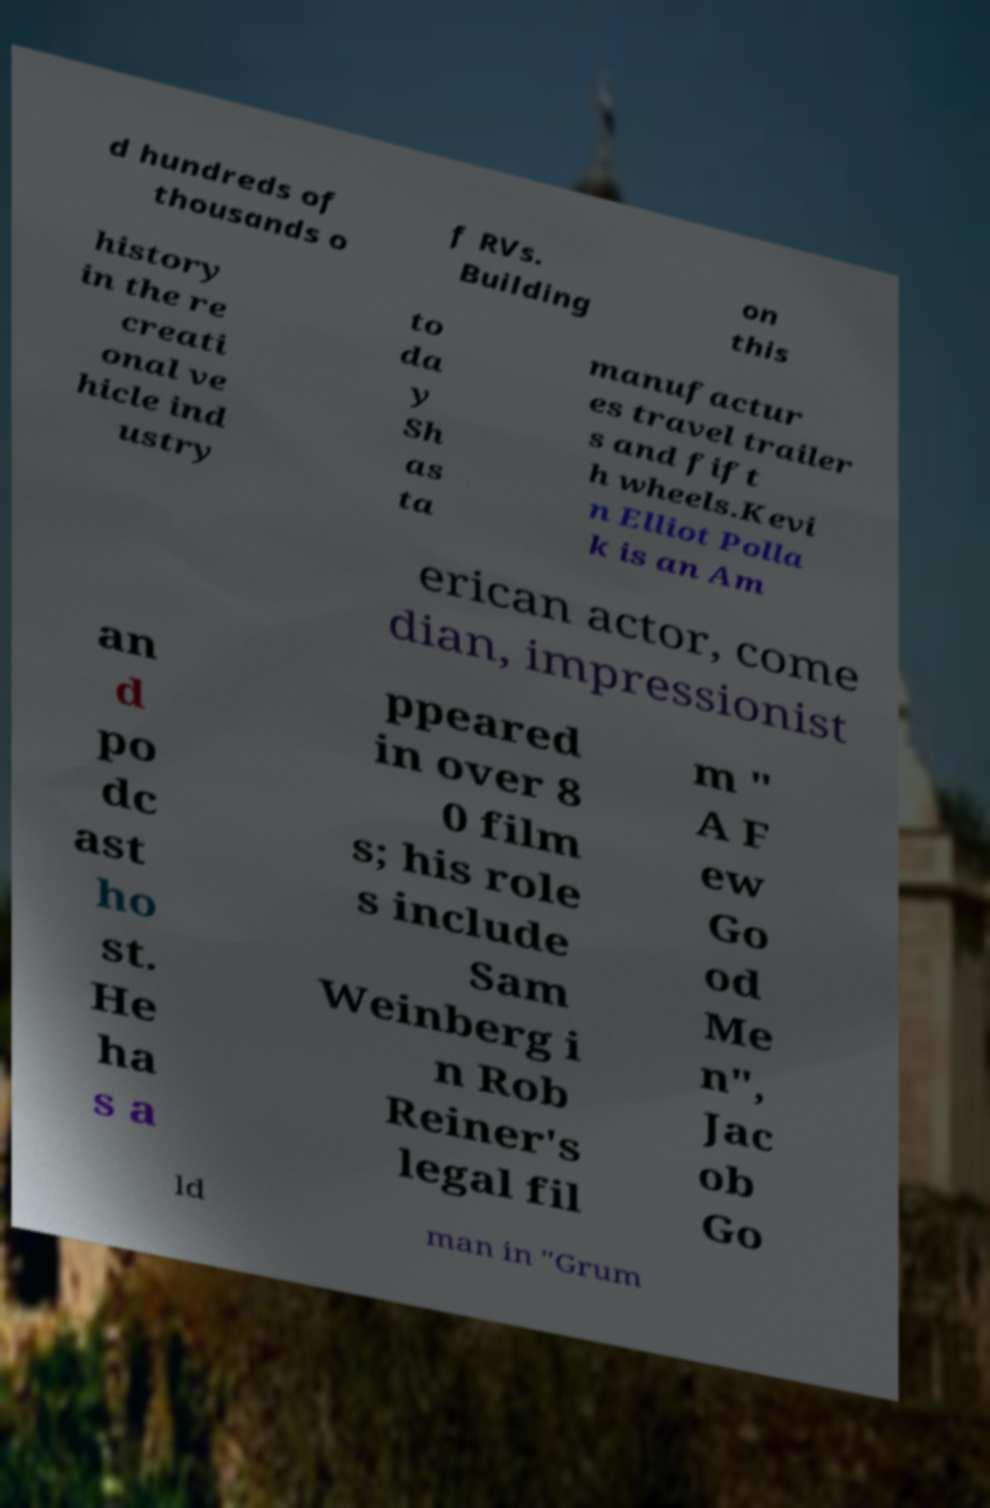Please identify and transcribe the text found in this image. d hundreds of thousands o f RVs. Building on this history in the re creati onal ve hicle ind ustry to da y Sh as ta manufactur es travel trailer s and fift h wheels.Kevi n Elliot Polla k is an Am erican actor, come dian, impressionist an d po dc ast ho st. He ha s a ppeared in over 8 0 film s; his role s include Sam Weinberg i n Rob Reiner's legal fil m " A F ew Go od Me n", Jac ob Go ld man in "Grum 